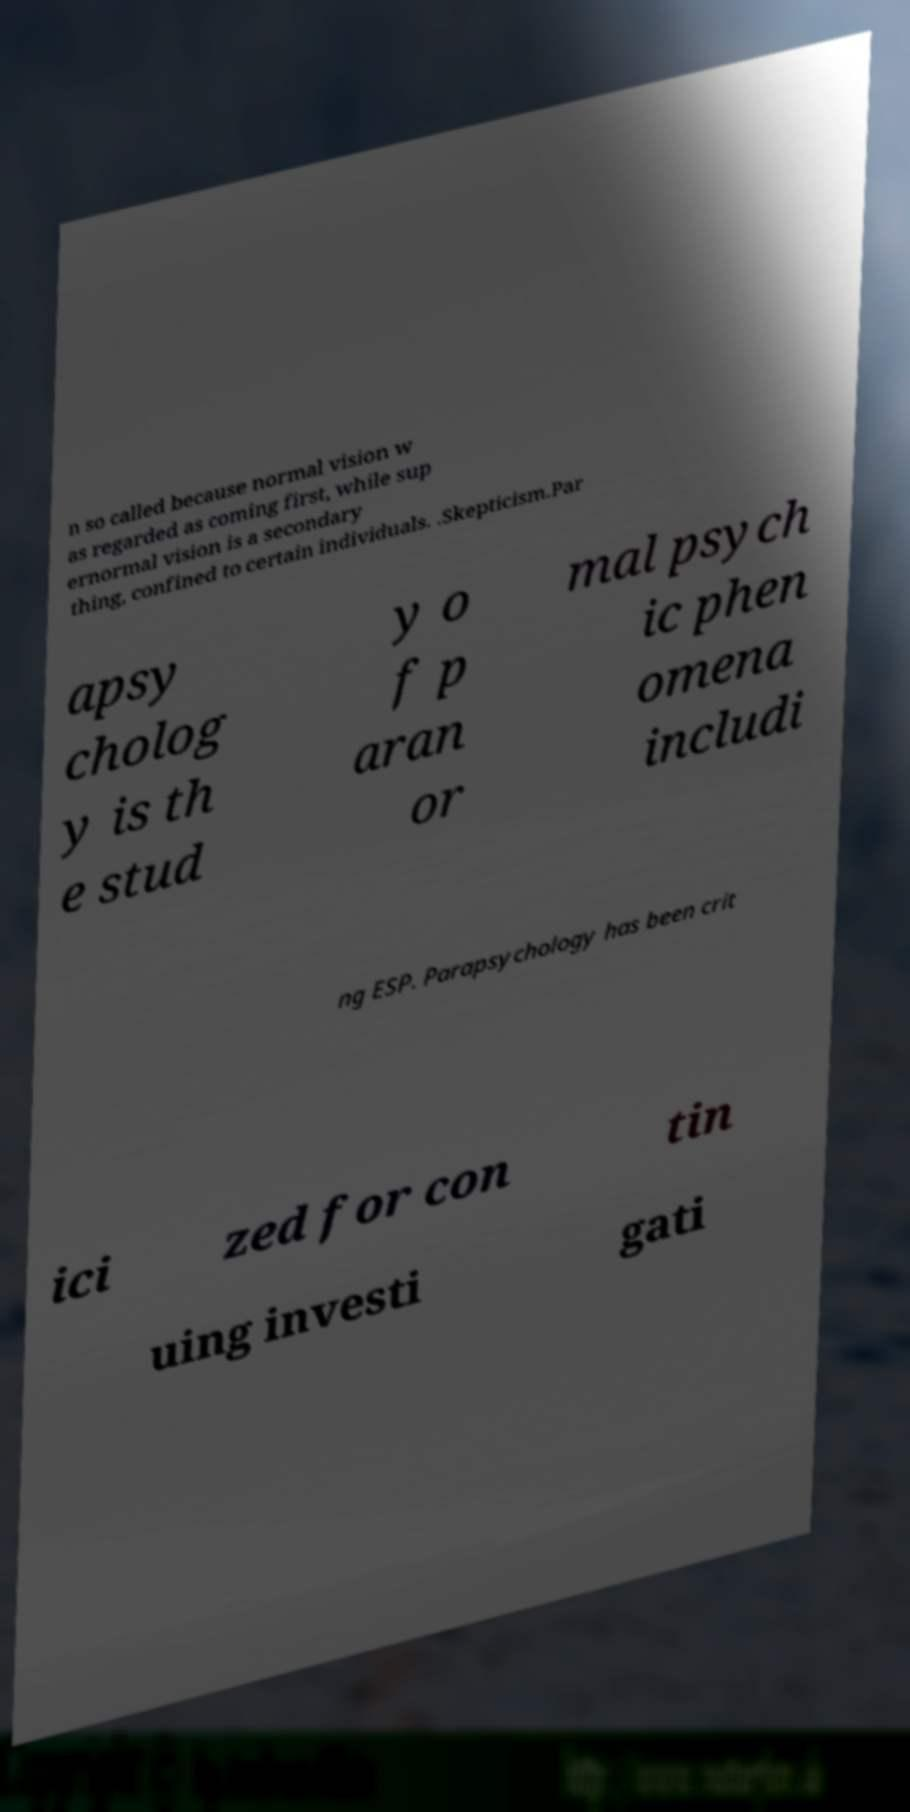Can you accurately transcribe the text from the provided image for me? n so called because normal vision w as regarded as coming first, while sup ernormal vision is a secondary thing, confined to certain individuals. .Skepticism.Par apsy cholog y is th e stud y o f p aran or mal psych ic phen omena includi ng ESP. Parapsychology has been crit ici zed for con tin uing investi gati 